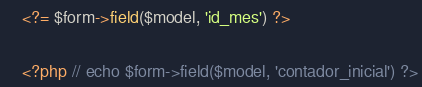<code> <loc_0><loc_0><loc_500><loc_500><_PHP_>    <?= $form->field($model, 'id_mes') ?>

    <?php // echo $form->field($model, 'contador_inicial') ?>
</code> 